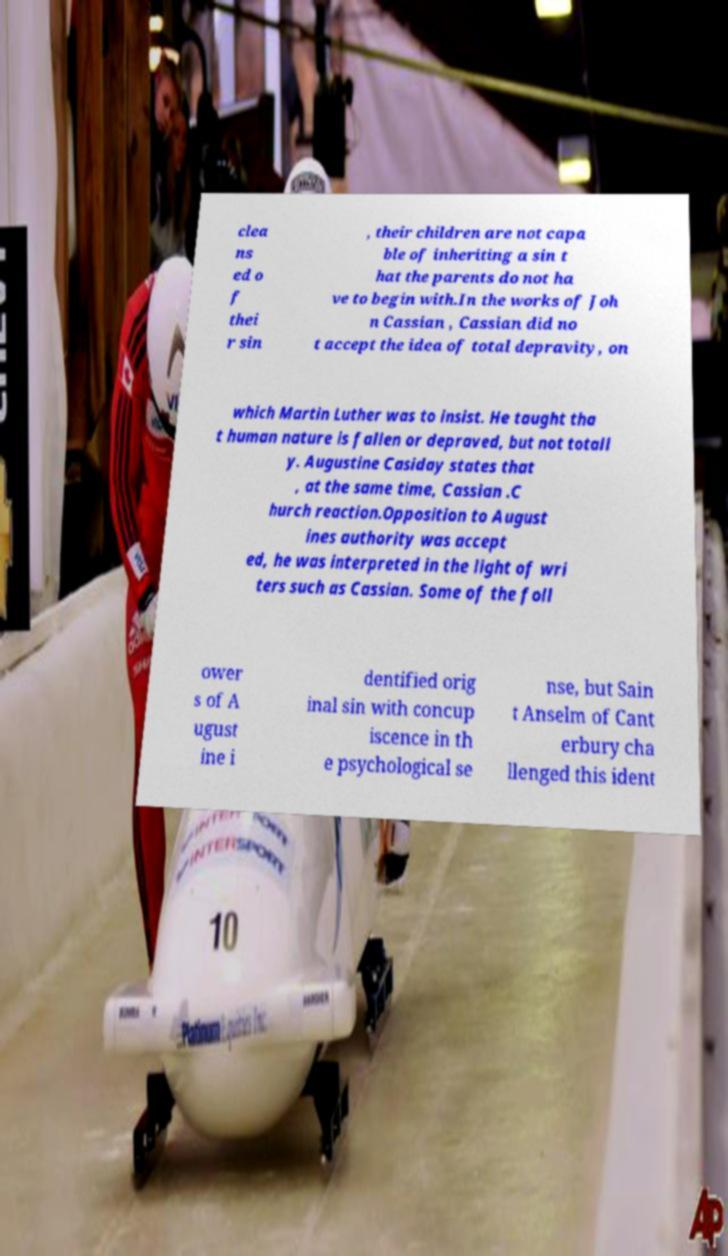There's text embedded in this image that I need extracted. Can you transcribe it verbatim? clea ns ed o f thei r sin , their children are not capa ble of inheriting a sin t hat the parents do not ha ve to begin with.In the works of Joh n Cassian , Cassian did no t accept the idea of total depravity, on which Martin Luther was to insist. He taught tha t human nature is fallen or depraved, but not totall y. Augustine Casiday states that , at the same time, Cassian .C hurch reaction.Opposition to August ines authority was accept ed, he was interpreted in the light of wri ters such as Cassian. Some of the foll ower s of A ugust ine i dentified orig inal sin with concup iscence in th e psychological se nse, but Sain t Anselm of Cant erbury cha llenged this ident 